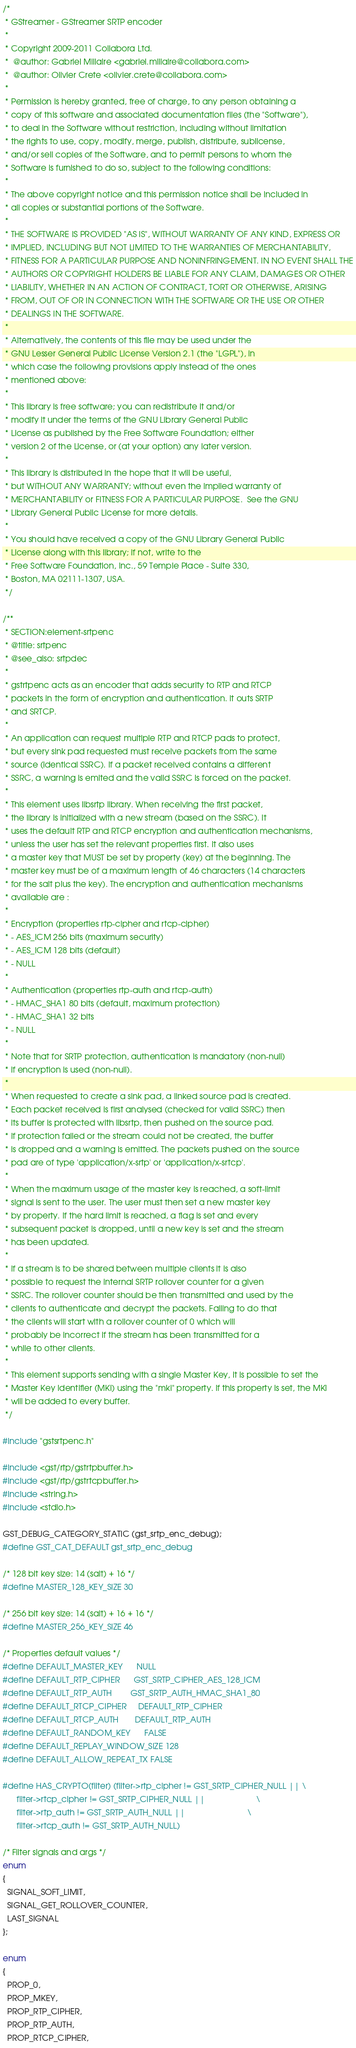Convert code to text. <code><loc_0><loc_0><loc_500><loc_500><_C_>/*
 * GStreamer - GStreamer SRTP encoder
 *
 * Copyright 2009-2011 Collabora Ltd.
 *  @author: Gabriel Millaire <gabriel.millaire@collabora.com>
 *  @author: Olivier Crete <olivier.crete@collabora.com>
 *
 * Permission is hereby granted, free of charge, to any person obtaining a
 * copy of this software and associated documentation files (the "Software"),
 * to deal in the Software without restriction, including without limitation
 * the rights to use, copy, modify, merge, publish, distribute, sublicense,
 * and/or sell copies of the Software, and to permit persons to whom the
 * Software is furnished to do so, subject to the following conditions:
 *
 * The above copyright notice and this permission notice shall be included in
 * all copies or substantial portions of the Software.
 *
 * THE SOFTWARE IS PROVIDED "AS IS", WITHOUT WARRANTY OF ANY KIND, EXPRESS OR
 * IMPLIED, INCLUDING BUT NOT LIMITED TO THE WARRANTIES OF MERCHANTABILITY,
 * FITNESS FOR A PARTICULAR PURPOSE AND NONINFRINGEMENT. IN NO EVENT SHALL THE
 * AUTHORS OR COPYRIGHT HOLDERS BE LIABLE FOR ANY CLAIM, DAMAGES OR OTHER
 * LIABILITY, WHETHER IN AN ACTION OF CONTRACT, TORT OR OTHERWISE, ARISING
 * FROM, OUT OF OR IN CONNECTION WITH THE SOFTWARE OR THE USE OR OTHER
 * DEALINGS IN THE SOFTWARE.
 *
 * Alternatively, the contents of this file may be used under the
 * GNU Lesser General Public License Version 2.1 (the "LGPL"), in
 * which case the following provisions apply instead of the ones
 * mentioned above:
 *
 * This library is free software; you can redistribute it and/or
 * modify it under the terms of the GNU Library General Public
 * License as published by the Free Software Foundation; either
 * version 2 of the License, or (at your option) any later version.
 *
 * This library is distributed in the hope that it will be useful,
 * but WITHOUT ANY WARRANTY; without even the implied warranty of
 * MERCHANTABILITY or FITNESS FOR A PARTICULAR PURPOSE.  See the GNU
 * Library General Public License for more details.
 *
 * You should have received a copy of the GNU Library General Public
 * License along with this library; if not, write to the
 * Free Software Foundation, Inc., 59 Temple Place - Suite 330,
 * Boston, MA 02111-1307, USA.
 */

/**
 * SECTION:element-srtpenc
 * @title: srtpenc
 * @see_also: srtpdec
 *
 * gstrtpenc acts as an encoder that adds security to RTP and RTCP
 * packets in the form of encryption and authentication. It outs SRTP
 * and SRTCP.
 *
 * An application can request multiple RTP and RTCP pads to protect,
 * but every sink pad requested must receive packets from the same
 * source (identical SSRC). If a packet received contains a different
 * SSRC, a warning is emited and the valid SSRC is forced on the packet.
 *
 * This element uses libsrtp library. When receiving the first packet,
 * the library is initialized with a new stream (based on the SSRC). It
 * uses the default RTP and RTCP encryption and authentication mechanisms,
 * unless the user has set the relevant properties first. It also uses
 * a master key that MUST be set by property (key) at the beginning. The
 * master key must be of a maximum length of 46 characters (14 characters
 * for the salt plus the key). The encryption and authentication mechanisms
 * available are :
 *
 * Encryption (properties rtp-cipher and rtcp-cipher)
 * - AES_ICM 256 bits (maximum security)
 * - AES_ICM 128 bits (default)
 * - NULL
 *
 * Authentication (properties rtp-auth and rtcp-auth)
 * - HMAC_SHA1 80 bits (default, maximum protection)
 * - HMAC_SHA1 32 bits
 * - NULL
 *
 * Note that for SRTP protection, authentication is mandatory (non-null)
 * if encryption is used (non-null).
 *
 * When requested to create a sink pad, a linked source pad is created.
 * Each packet received is first analysed (checked for valid SSRC) then
 * its buffer is protected with libsrtp, then pushed on the source pad.
 * If protection failed or the stream could not be created, the buffer
 * is dropped and a warning is emitted. The packets pushed on the source
 * pad are of type 'application/x-srtp' or 'application/x-srtcp'.
 *
 * When the maximum usage of the master key is reached, a soft-limit
 * signal is sent to the user. The user must then set a new master key
 * by property. If the hard limit is reached, a flag is set and every
 * subsequent packet is dropped, until a new key is set and the stream
 * has been updated.
 *
 * If a stream is to be shared between multiple clients it is also
 * possible to request the internal SRTP rollover counter for a given
 * SSRC. The rollover counter should be then transmitted and used by the
 * clients to authenticate and decrypt the packets. Failing to do that
 * the clients will start with a rollover counter of 0 which will
 * probably be incorrect if the stream has been transmitted for a
 * while to other clients.
 *
 * This element supports sending with a single Master Key, it is possible to set the
 * Master Key Identifier (MKI) using the "mki" property. If this property is set, the MKI
 * will be added to every buffer.
 */

#include "gstsrtpenc.h"

#include <gst/rtp/gstrtpbuffer.h>
#include <gst/rtp/gstrtcpbuffer.h>
#include <string.h>
#include <stdio.h>

GST_DEBUG_CATEGORY_STATIC (gst_srtp_enc_debug);
#define GST_CAT_DEFAULT gst_srtp_enc_debug

/* 128 bit key size: 14 (salt) + 16 */
#define MASTER_128_KEY_SIZE 30

/* 256 bit key size: 14 (salt) + 16 + 16 */
#define MASTER_256_KEY_SIZE 46

/* Properties default values */
#define DEFAULT_MASTER_KEY      NULL
#define DEFAULT_RTP_CIPHER      GST_SRTP_CIPHER_AES_128_ICM
#define DEFAULT_RTP_AUTH        GST_SRTP_AUTH_HMAC_SHA1_80
#define DEFAULT_RTCP_CIPHER     DEFAULT_RTP_CIPHER
#define DEFAULT_RTCP_AUTH       DEFAULT_RTP_AUTH
#define DEFAULT_RANDOM_KEY      FALSE
#define DEFAULT_REPLAY_WINDOW_SIZE 128
#define DEFAULT_ALLOW_REPEAT_TX FALSE

#define HAS_CRYPTO(filter) (filter->rtp_cipher != GST_SRTP_CIPHER_NULL || \
      filter->rtcp_cipher != GST_SRTP_CIPHER_NULL ||                      \
      filter->rtp_auth != GST_SRTP_AUTH_NULL ||                           \
      filter->rtcp_auth != GST_SRTP_AUTH_NULL)

/* Filter signals and args */
enum
{
  SIGNAL_SOFT_LIMIT,
  SIGNAL_GET_ROLLOVER_COUNTER,
  LAST_SIGNAL
};

enum
{
  PROP_0,
  PROP_MKEY,
  PROP_RTP_CIPHER,
  PROP_RTP_AUTH,
  PROP_RTCP_CIPHER,</code> 